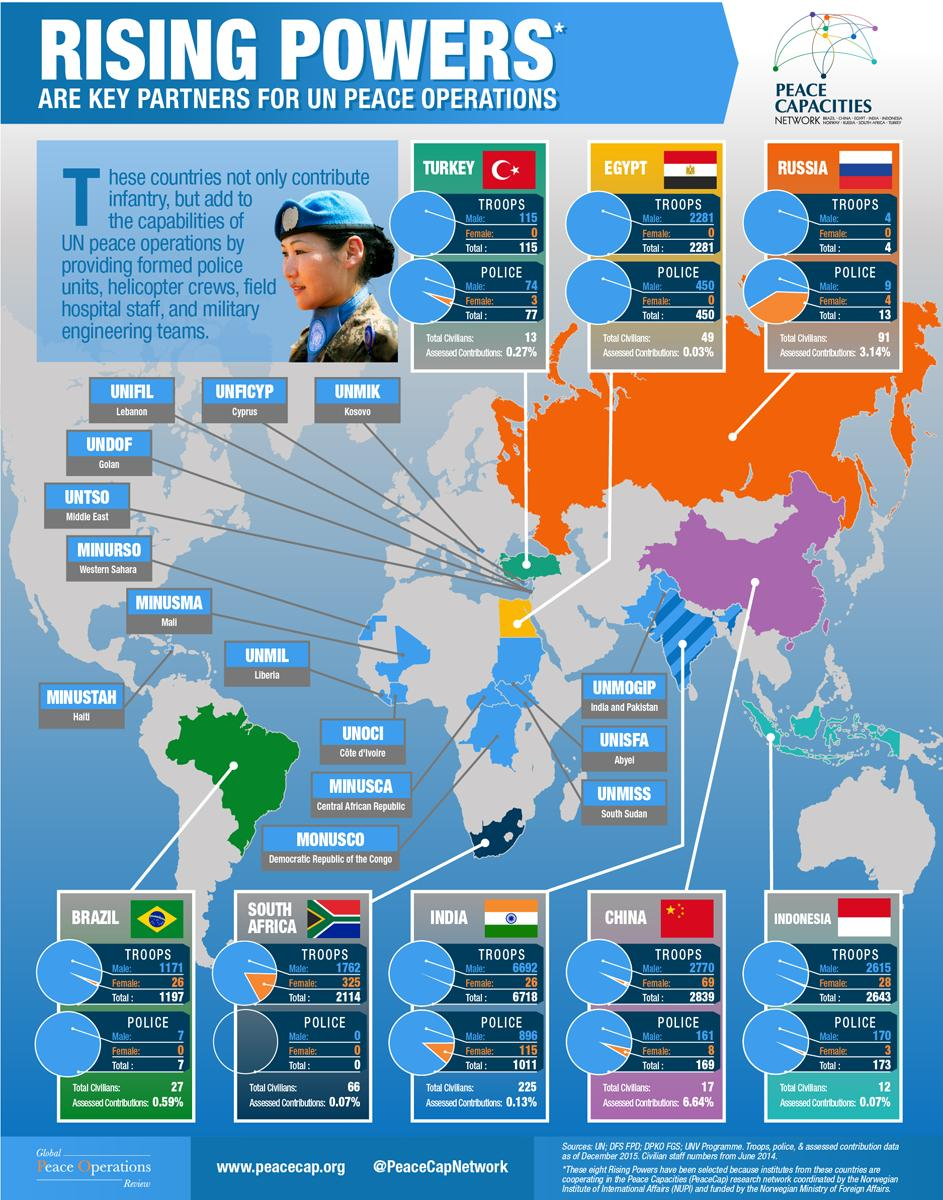Highlight a few significant elements in this photo. India's assessed contributions for UN peace operations are only 0.13%. The Brazilian police force has contributed a total of 7 individuals to serve in United Nations peace operations. It is estimated that 2,770 male soldiers from China were serving in UN peace operations as of 2021. As of 2021, there are 2,281 Egyptian troops serving in United Nations peace operations. There are 26 females among the Indian troops serving in UN peace operations. 